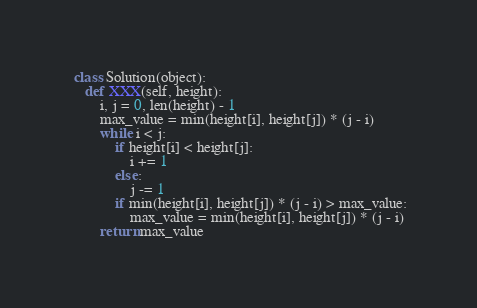Convert code to text. <code><loc_0><loc_0><loc_500><loc_500><_Python_> class Solution(object):
    def XXX(self, height):
        i, j = 0, len(height) - 1
        max_value = min(height[i], height[j]) * (j - i)
        while i < j:
            if height[i] < height[j]:
                i += 1
            else:
                j -= 1
            if min(height[i], height[j]) * (j - i) > max_value:
                max_value = min(height[i], height[j]) * (j - i)
        return max_value

</code> 